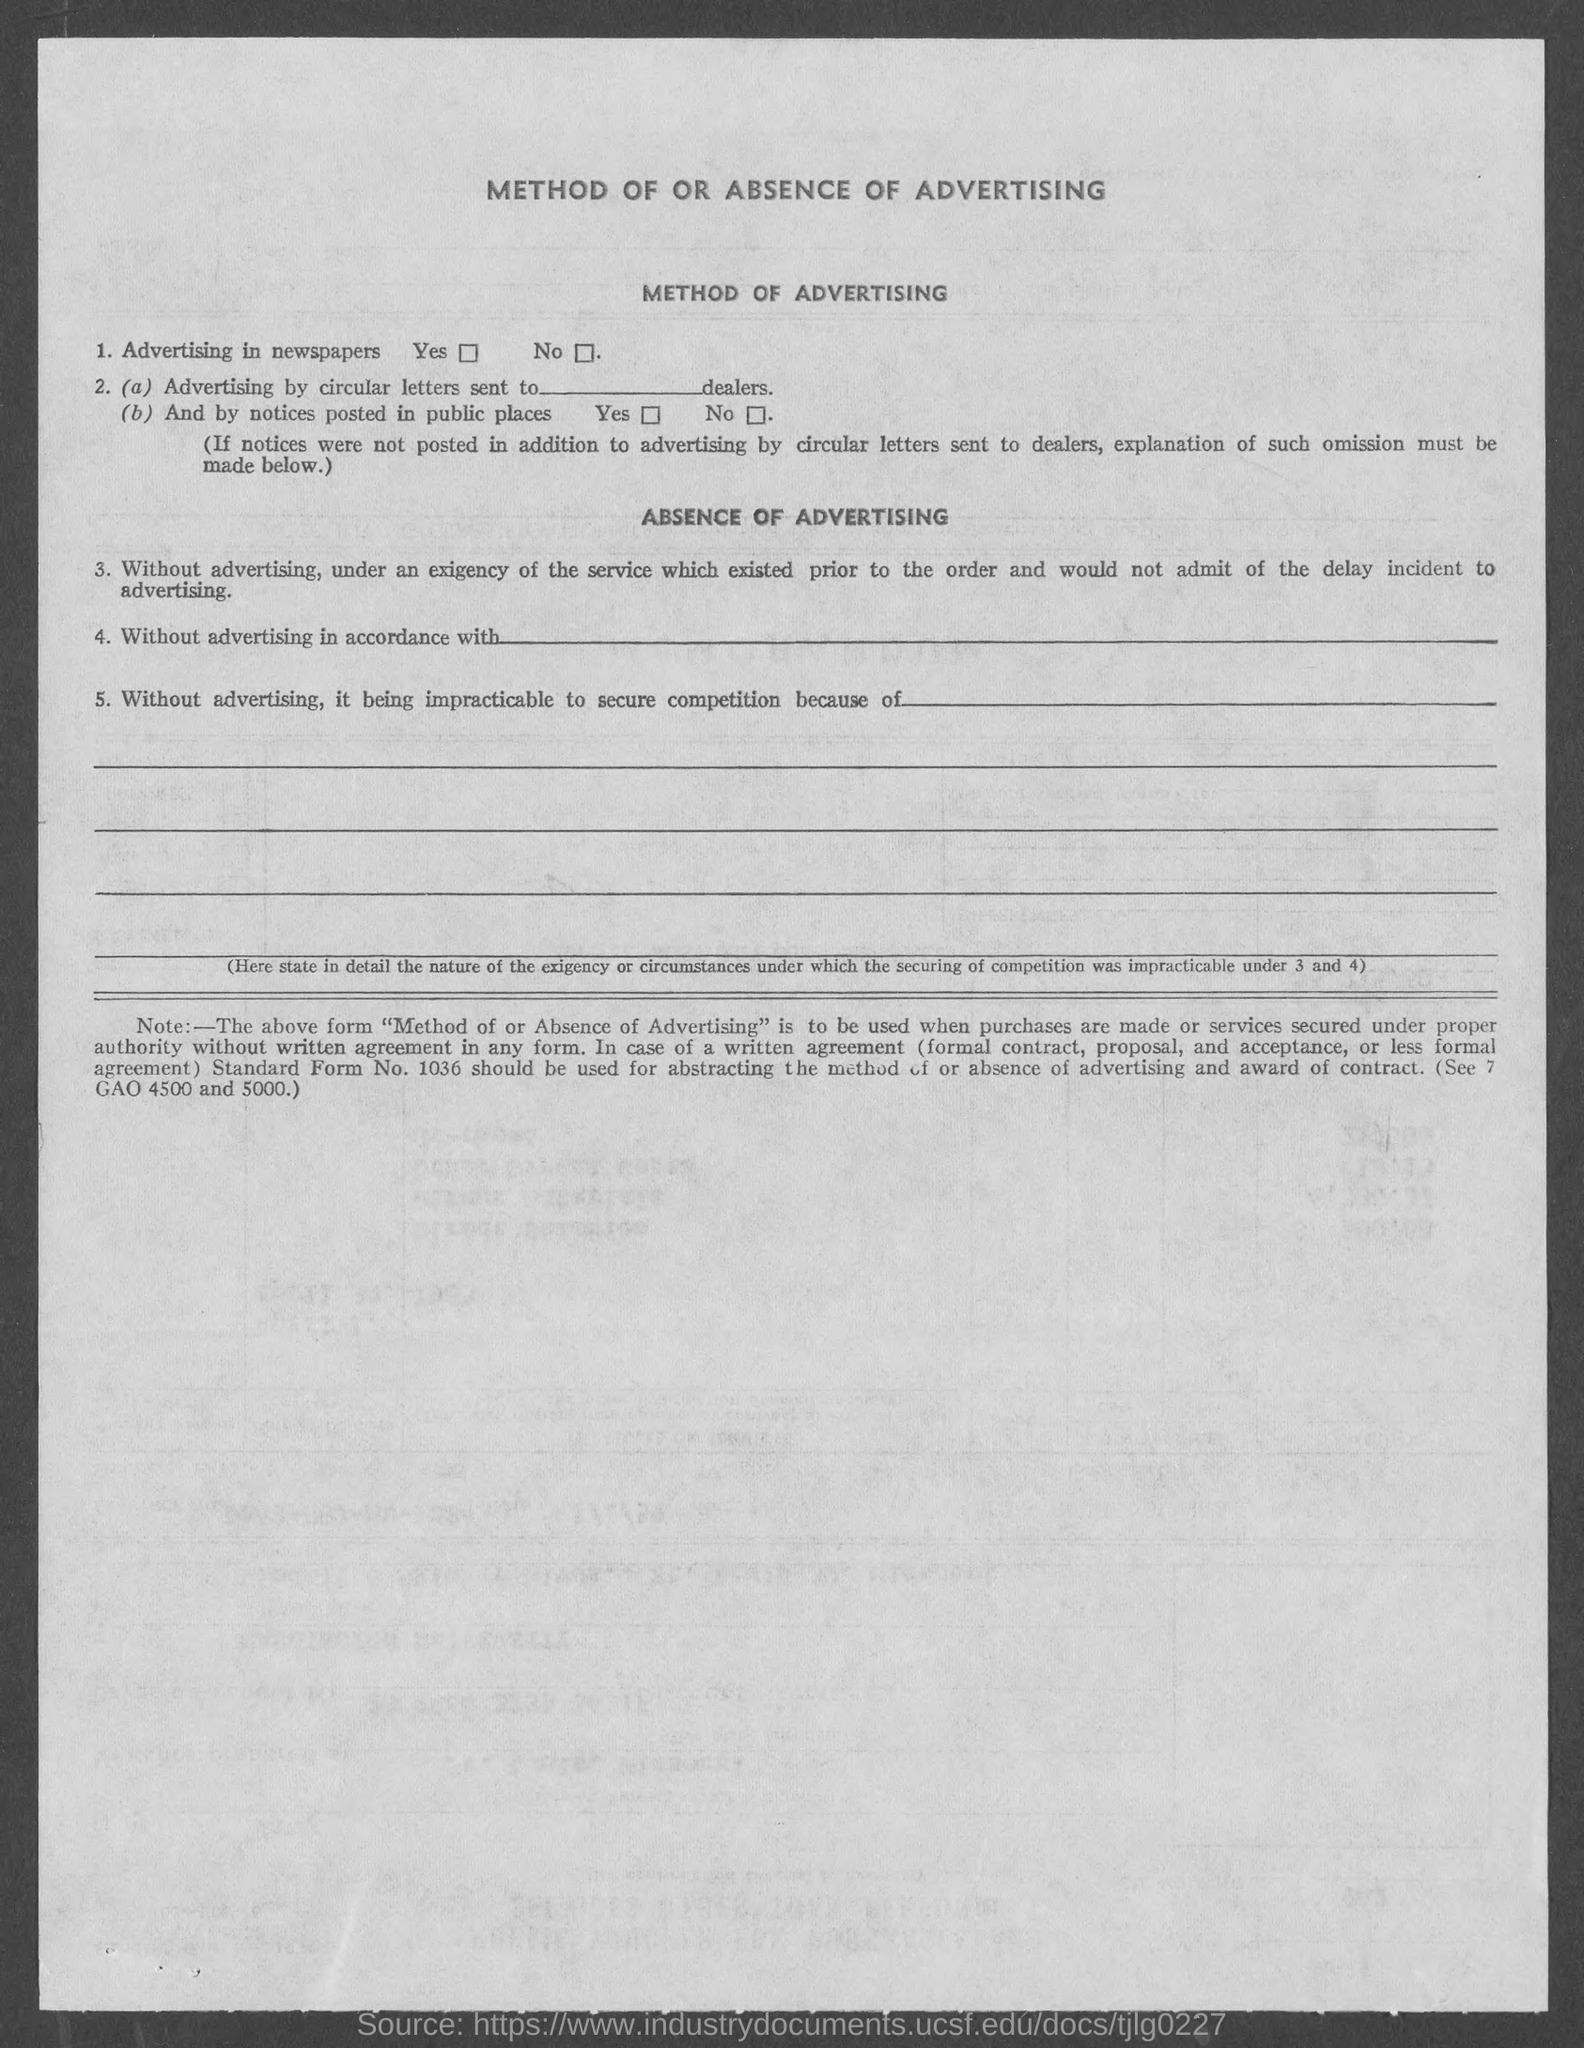What is the heading at top of the page ?
Provide a short and direct response. METHOD OF OR ABSENCE OF ADVERTISING. 